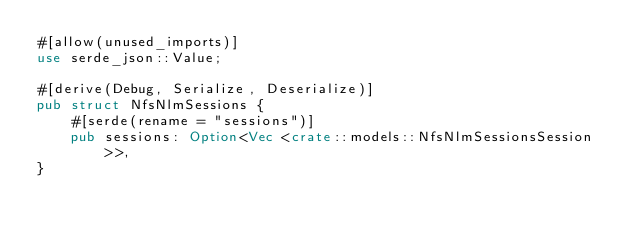Convert code to text. <code><loc_0><loc_0><loc_500><loc_500><_Rust_>#[allow(unused_imports)]
use serde_json::Value;

#[derive(Debug, Serialize, Deserialize)]
pub struct NfsNlmSessions {
    #[serde(rename = "sessions")]
    pub sessions: Option<Vec <crate::models::NfsNlmSessionsSession>>,
}
</code> 